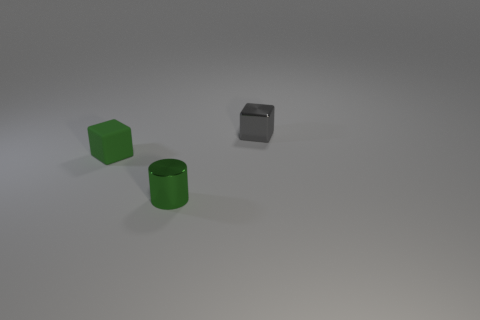Add 3 tiny rubber things. How many objects exist? 6 Subtract all cylinders. How many objects are left? 2 Subtract 1 gray blocks. How many objects are left? 2 Subtract all metallic cylinders. Subtract all gray cubes. How many objects are left? 1 Add 2 tiny objects. How many tiny objects are left? 5 Add 1 tiny green things. How many tiny green things exist? 3 